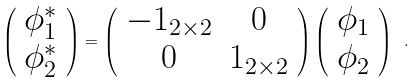<formula> <loc_0><loc_0><loc_500><loc_500>\left ( \begin{array} { c } \phi _ { 1 } ^ { \ast } \\ \phi _ { 2 } ^ { \ast } \end{array} \right ) = \left ( \begin{array} { c c } - 1 _ { 2 \times 2 } & 0 \\ 0 & 1 _ { 2 \times 2 } \end{array} \right ) \left ( \begin{array} { c } \phi _ { 1 } \\ \phi _ { 2 } \end{array} \right ) \ .</formula> 